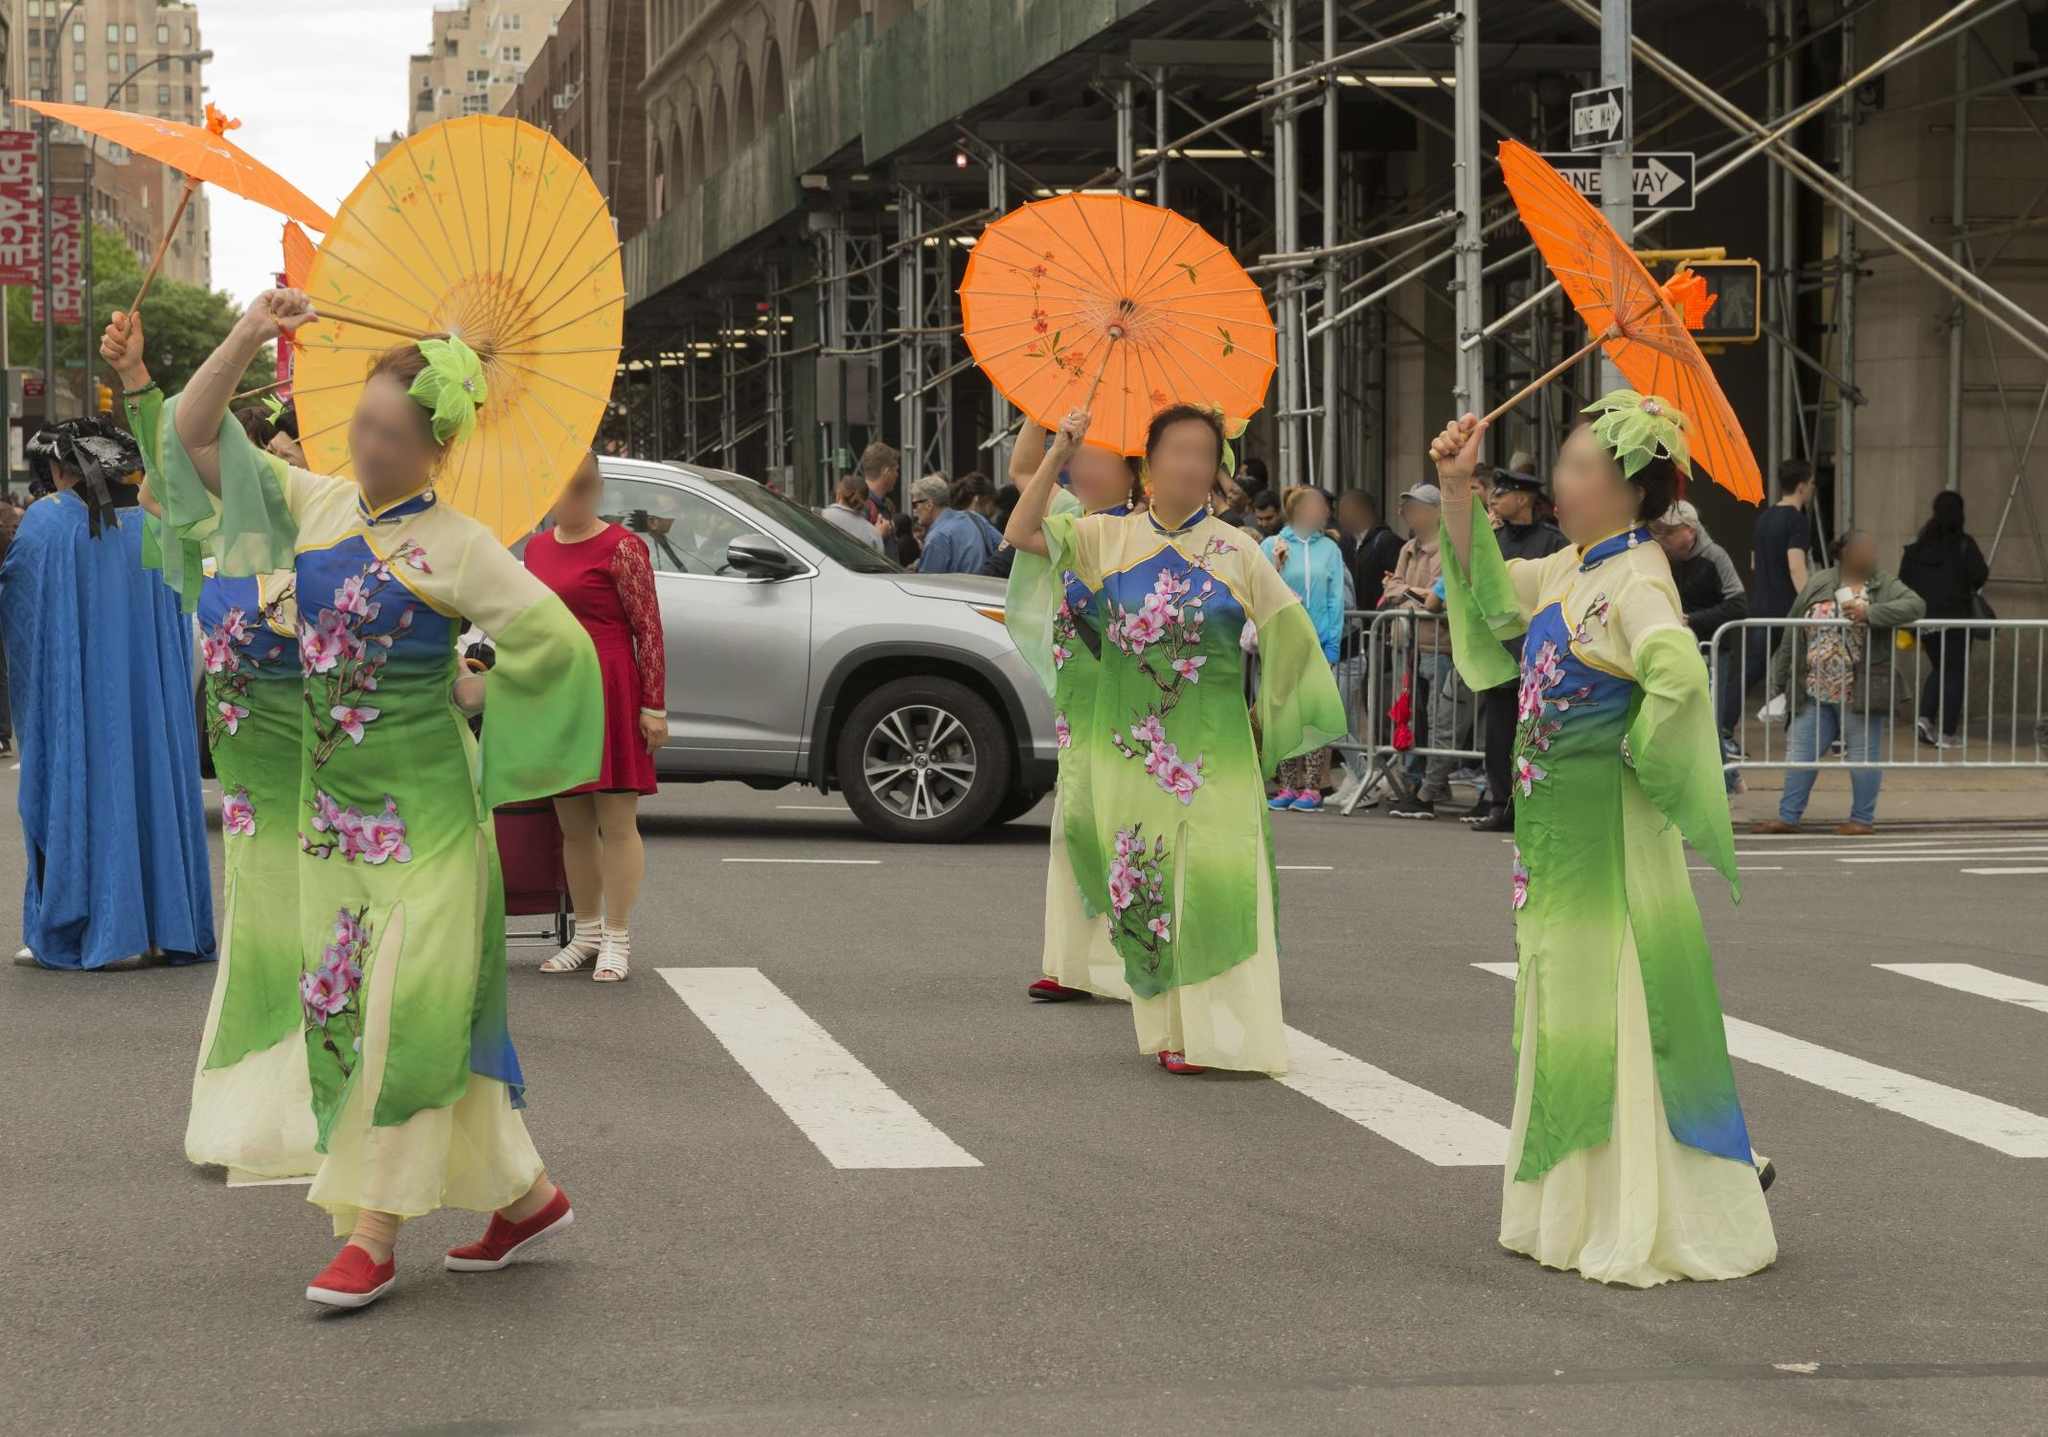If this image were a painting, how might the artist have captured its essence? If this image were a painting, the artist would likely focus on capturing the vibrancy and movement of the parade. Using bold and vivid colors, the greens and oranges would stand out, creating a sense of liveliness and celebration. The brushstrokes might be fluid and dynamic to portray the graceful motion of the women and the fluttering fabric of their kimonos. Attention to detail would be evident in the intricate floral designs on the attire and the ornate patterns on the parasols. The background, with its urban setting, might be slightly blurred to emphasize the prominence of the women and the festive atmosphere. This artistic interpretation would convey the cultural richness and joyful spirit of the scene. 